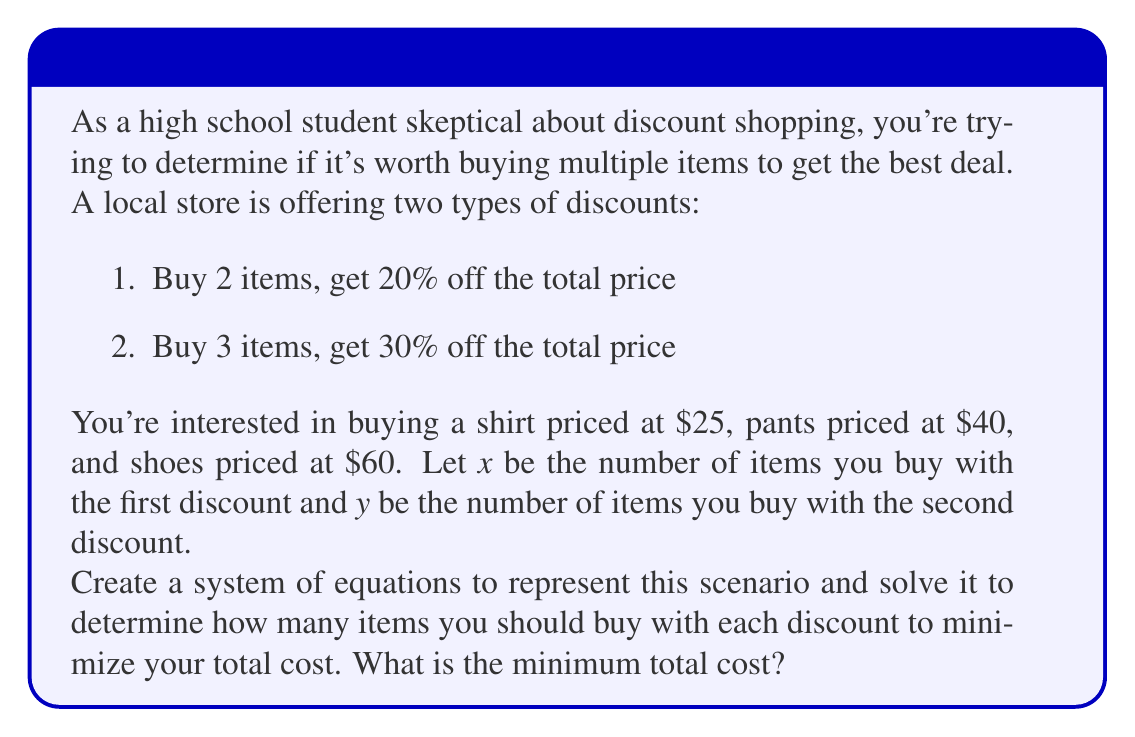Can you answer this question? Let's approach this step-by-step:

1) First, we need to set up our equations. We have two constraints:
   a) The total number of items must be 3 (shirt, pants, and shoes)
   b) The total price must be minimized

2) For the first equation:
   $x + y = 3$

3) For the second equation, we need to consider the discounted prices:
   - With the first discount (20% off for 2 items), each item costs 80% of its original price
   - With the second discount (30% off for 3 items), each item costs 70% of its original price

   Let's call the total cost $C$. Then:
   $C = 0.8(25x_1 + 40x_2 + 60x_3) + 0.7(25y_1 + 40y_2 + 60y_3)$
   where $x_1 + x_2 + x_3 = 2x$ and $y_1 + y_2 + y_3 = 3y$

4) To simplify, let's use the average price of the items: $(25 + 40 + 60)/3 = 41.67$

   Now our cost equation becomes:
   $C = 0.8(41.67 \cdot 2x) + 0.7(41.67 \cdot 3y)$
   $C = 66.67x + 87.5y$

5) Our goal is to minimize $C$ subject to the constraint $x + y = 3$

6) We can solve this by substitution. Let $y = 3 - x$:
   $C = 66.67x + 87.5(3 - x)$
   $C = 66.67x + 262.5 - 87.5x$
   $C = 262.5 - 20.83x$

7) To minimize $C$, we want to maximize $x$ (since the coefficient of $x$ is negative).
   The maximum value $x$ can take is 1, because $x$ represents pairs of items, and we only have 3 items total.

8) Therefore, the optimal solution is $x = 1$ and $y = 2$

9) The minimum cost is:
   $C = 262.5 - 20.83(1) = 241.67$
Answer: The optimal way to purchase the items is to buy 2 items with the first discount (20% off) and 1 item with the second discount (30% off). The minimum total cost is $241.67. 